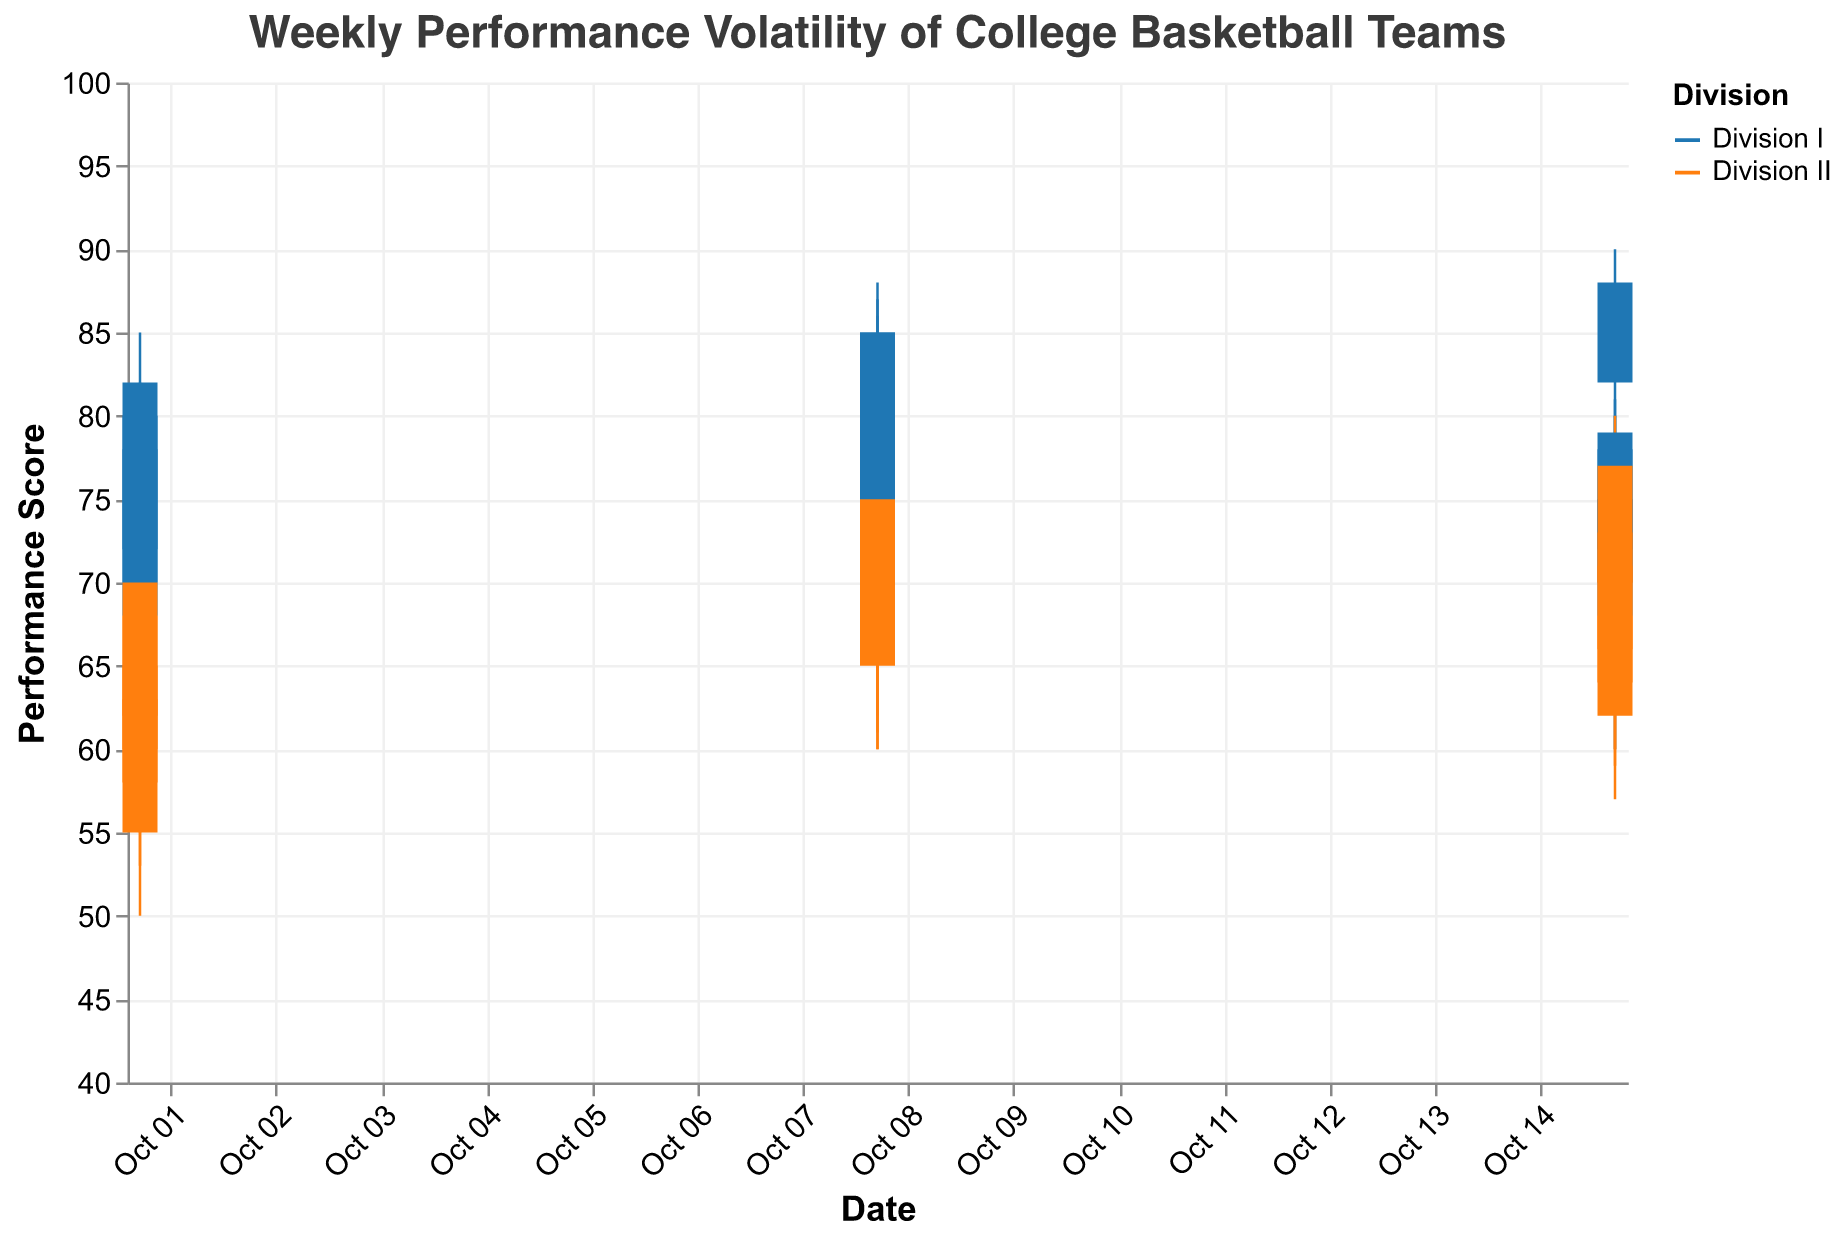What is the title of the plot? The title is positioned at the top of the plot and reads "Weekly Performance Volatility of College Basketball Teams".
Answer: Weekly Performance Volatility of College Basketball Teams What is the range of the y-axis? The y-axis ranges from 40 to 100, as indicated by the axis labels.
Answer: 40 to 100 Which divisions are represented by different colors, and what are those colors? Division I is colored in blue, and Division II is colored in orange, according to the legend.
Answer: Division I: blue, Division II: orange Which Division I team had the highest closing performance score on October 15, 2023? The team with the highest closing performance score on October 15, 2023, in Division I is the Gonzaga Bulldogs with a closing score of 88, as indicated by the candlestick bars.
Answer: Gonzaga Bulldogs Comparing Division I and Division II, which division had the highest high-performance score on October 08, 2023? Division I had the highest high-performance score of 88 (UCLA Bruins), while Division II's highest high-performance score was 77 (Arizona Wildcats).
Answer: Division I How many Division II teams closed with a performance score of 70 or above on October 08, 2023? The teams that closed with a performance score of 70 or above on October 08, 2023, in Division II were UCLA Bruins (70), Kansas Jayhawks (74), North Carolina Tar Heels (73), and Arizona Wildcats (75). That's 4 teams.
Answer: 4 On October 01, 2023, for Division II, which team had the largest range between the high and low performance scores? The range between high and low performance scores for Division II on October 01, 2023, is largest for the Duke Blue Devils, with a high of 65 and a low of 50, resulting in a range of 15.
Answer: Duke Blue Devils Did any team in Division I have a closing score lower than their opening score on October 15, 2023? None of the Division I teams had a closing score lower than their opening score on October 15, 2023, as all closing scores are equal to or greater than their opening scores.
Answer: No Which Division I team had the smallest fluctuation in performance score (difference between high and low) on October 01, 2023? The team with the smallest fluctuation is the Duke Blue Devils with a fluctuation of 15 (High 85 - Low 70).
Answer: Duke Blue Devils 